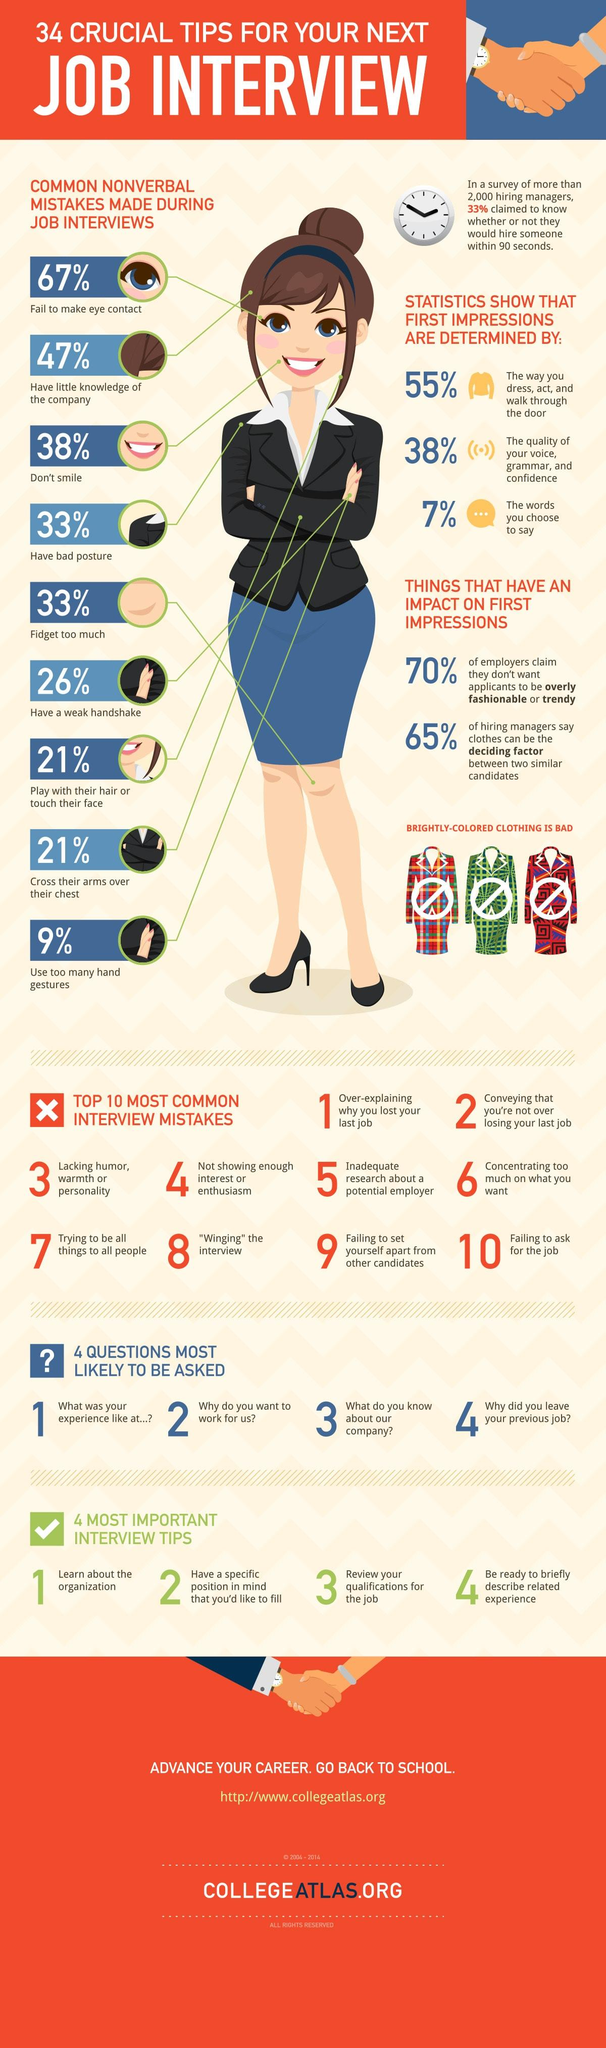Mention a couple of crucial points in this snapshot. According to a recent survey, 33% of people are prone to fidgeting excessively. This is the third interview, please review your qualifications for the job. In the end, what may determine which candidate is more suitable may be their clothing choices. A significant number of people believe that someone could be hired within 90 seconds. In fact, over 2000 people hold this belief. The quality of your voice, grammar, and confidence are the second most important factors that determine first impressions. 